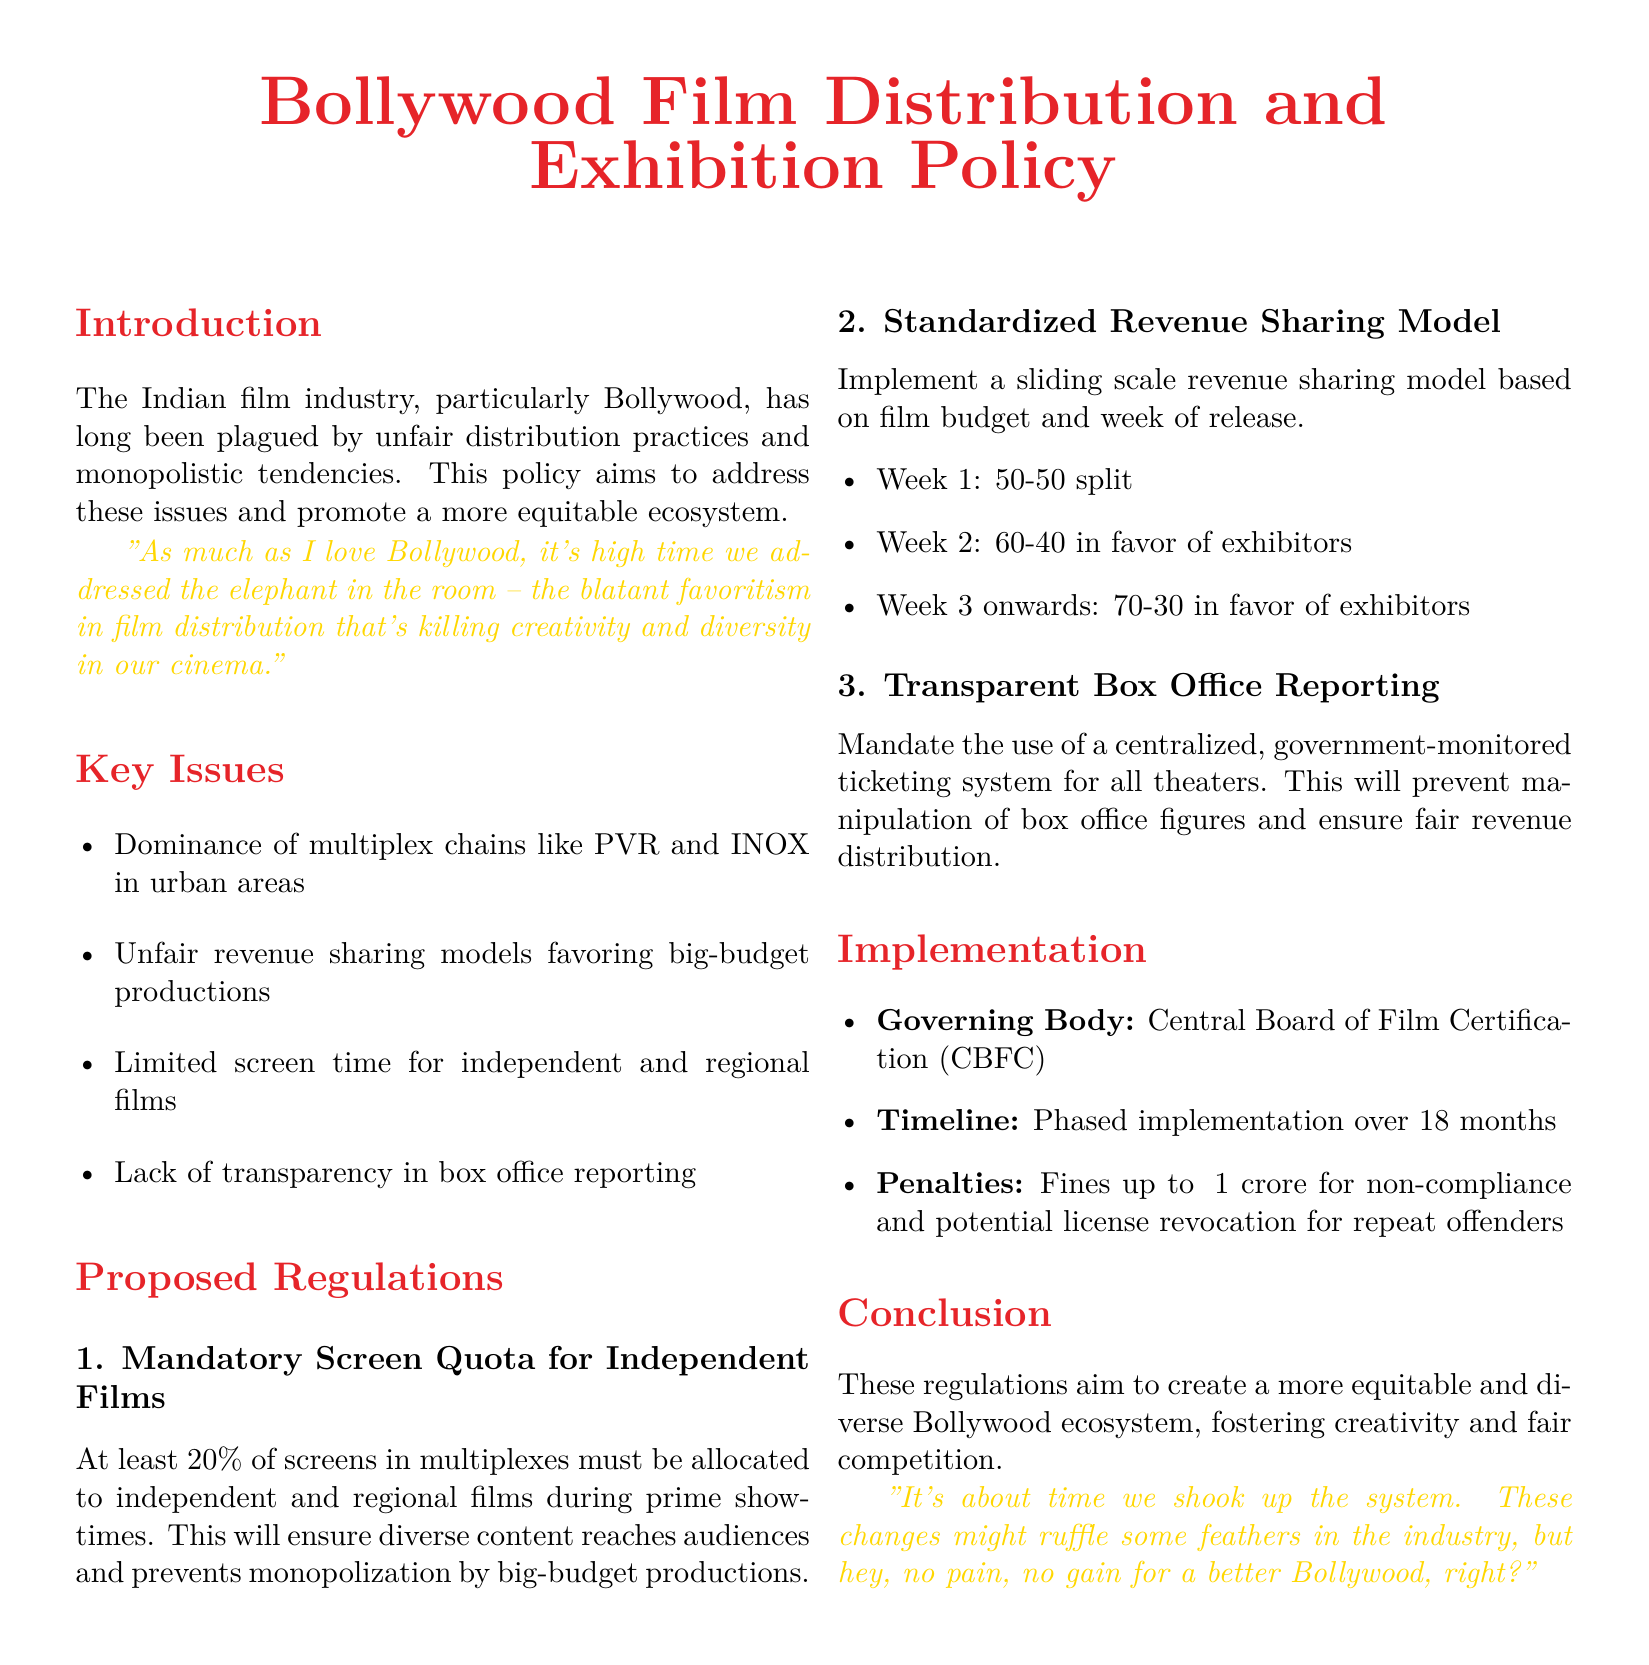What is the minimum screen quota for independent films? The document states that at least 20% of screens in multiplexes must be allocated to independent and regional films during prime showtimes.
Answer: 20% What is the revenue split in the first week of release? According to the proposed regulations, the revenue sharing model for the first week is a 50-50 split.
Answer: 50-50 Who will govern the implementation of the proposed regulations? The governing body responsible for the implementation is mentioned in the document as the Central Board of Film Certification (CBFC).
Answer: CBFC What is the penalty for non-compliance? The document specifies fines up to ₹1 crore for non-compliance and potential license revocation for repeat offenders.
Answer: ₹1 crore What does the policy aim to address? The main aim of the policy is to address unfair distribution practices and monopolistic tendencies in the Bollywood film industry.
Answer: Unfair distribution practices How long is the proposed implementation timeline? The timeline for the phased implementation of the regulations is stated to be over 18 months.
Answer: 18 months What is the revenue share in the second week? In the second week of release, the revenue sharing model favors exhibitors with a 60-40 split.
Answer: 60-40 What issue regarding screen time does the policy address? The policy addresses the limited screen time allotted to independent and regional films.
Answer: Limited screen time What is the proposed system for box office reporting? The proposed regulation mandates the use of a centralized, government-monitored ticketing system for all theaters.
Answer: Centralized ticketing system 